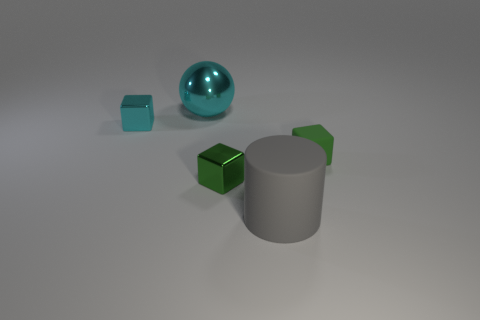Is there anything else that is the same shape as the big cyan metallic thing?
Offer a terse response. No. How many objects are either cyan blocks or large cyan spheres?
Keep it short and to the point. 2. What shape is the big cyan object that is made of the same material as the small cyan block?
Offer a terse response. Sphere. There is a matte thing that is on the left side of the green block to the right of the rubber cylinder; what size is it?
Your answer should be very brief. Large. How many big things are either yellow metallic spheres or rubber blocks?
Offer a terse response. 0. How many other things are the same color as the cylinder?
Offer a very short reply. 0. Does the block to the right of the large rubber thing have the same size as the cyan ball left of the small green matte block?
Your response must be concise. No. Are the large cylinder and the large thing behind the cyan cube made of the same material?
Your response must be concise. No. Is the number of large matte cylinders that are behind the matte cylinder greater than the number of gray things right of the small green rubber block?
Keep it short and to the point. No. There is a tiny metal object in front of the green thing right of the gray thing; what is its color?
Give a very brief answer. Green. 